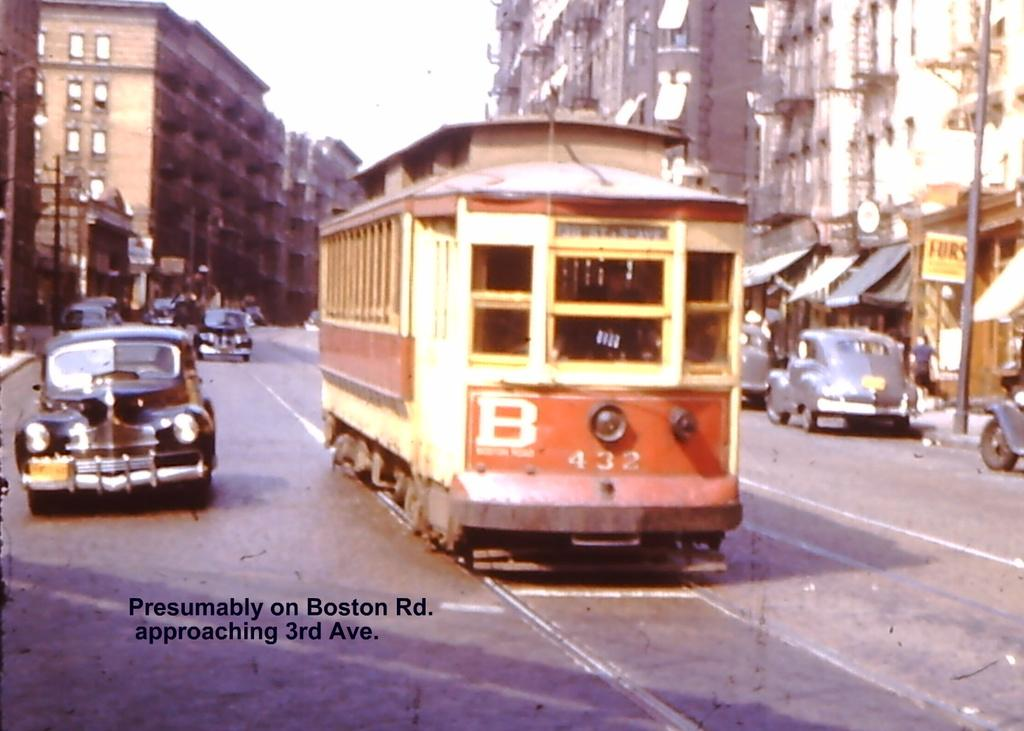Provide a one-sentence caption for the provided image. Bus with the numbers 432 on it going down a road. 